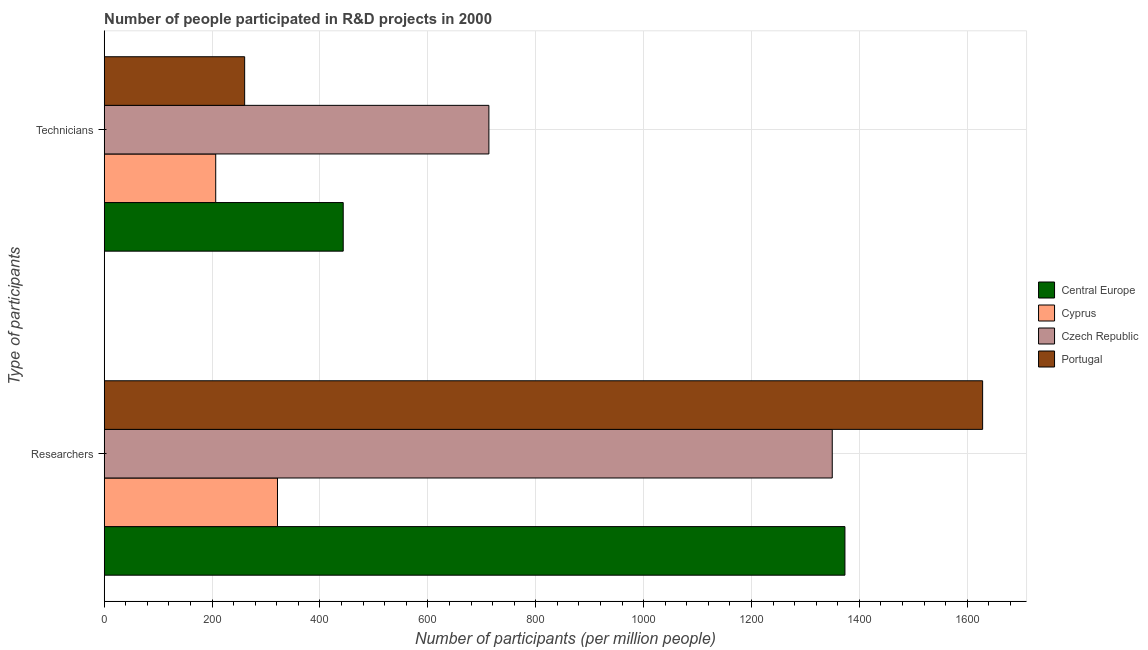How many groups of bars are there?
Provide a short and direct response. 2. Are the number of bars on each tick of the Y-axis equal?
Offer a terse response. Yes. What is the label of the 2nd group of bars from the top?
Make the answer very short. Researchers. What is the number of technicians in Czech Republic?
Provide a short and direct response. 713.14. Across all countries, what is the maximum number of technicians?
Offer a terse response. 713.14. Across all countries, what is the minimum number of researchers?
Ensure brevity in your answer.  321.22. In which country was the number of researchers maximum?
Make the answer very short. Portugal. In which country was the number of technicians minimum?
Ensure brevity in your answer.  Cyprus. What is the total number of technicians in the graph?
Your response must be concise. 1623.32. What is the difference between the number of researchers in Central Europe and that in Czech Republic?
Provide a short and direct response. 23.52. What is the difference between the number of researchers in Central Europe and the number of technicians in Portugal?
Offer a terse response. 1112.86. What is the average number of researchers per country?
Make the answer very short. 1168.15. What is the difference between the number of technicians and number of researchers in Central Europe?
Provide a succinct answer. -930.13. In how many countries, is the number of technicians greater than 640 ?
Offer a terse response. 1. What is the ratio of the number of technicians in Central Europe to that in Czech Republic?
Make the answer very short. 0.62. Is the number of technicians in Portugal less than that in Cyprus?
Offer a terse response. No. What does the 1st bar from the bottom in Technicians represents?
Keep it short and to the point. Central Europe. How many countries are there in the graph?
Keep it short and to the point. 4. Does the graph contain grids?
Provide a succinct answer. Yes. How are the legend labels stacked?
Your answer should be very brief. Vertical. What is the title of the graph?
Give a very brief answer. Number of people participated in R&D projects in 2000. What is the label or title of the X-axis?
Your answer should be very brief. Number of participants (per million people). What is the label or title of the Y-axis?
Give a very brief answer. Type of participants. What is the Number of participants (per million people) in Central Europe in Researchers?
Your answer should be very brief. 1373.22. What is the Number of participants (per million people) of Cyprus in Researchers?
Make the answer very short. 321.22. What is the Number of participants (per million people) of Czech Republic in Researchers?
Give a very brief answer. 1349.7. What is the Number of participants (per million people) in Portugal in Researchers?
Keep it short and to the point. 1628.47. What is the Number of participants (per million people) of Central Europe in Technicians?
Keep it short and to the point. 443.09. What is the Number of participants (per million people) of Cyprus in Technicians?
Keep it short and to the point. 206.72. What is the Number of participants (per million people) in Czech Republic in Technicians?
Make the answer very short. 713.14. What is the Number of participants (per million people) in Portugal in Technicians?
Your answer should be very brief. 260.36. Across all Type of participants, what is the maximum Number of participants (per million people) of Central Europe?
Make the answer very short. 1373.22. Across all Type of participants, what is the maximum Number of participants (per million people) in Cyprus?
Provide a short and direct response. 321.22. Across all Type of participants, what is the maximum Number of participants (per million people) in Czech Republic?
Give a very brief answer. 1349.7. Across all Type of participants, what is the maximum Number of participants (per million people) in Portugal?
Your answer should be compact. 1628.47. Across all Type of participants, what is the minimum Number of participants (per million people) of Central Europe?
Your answer should be very brief. 443.09. Across all Type of participants, what is the minimum Number of participants (per million people) in Cyprus?
Your answer should be compact. 206.72. Across all Type of participants, what is the minimum Number of participants (per million people) in Czech Republic?
Offer a terse response. 713.14. Across all Type of participants, what is the minimum Number of participants (per million people) of Portugal?
Your answer should be very brief. 260.36. What is the total Number of participants (per million people) of Central Europe in the graph?
Your answer should be very brief. 1816.32. What is the total Number of participants (per million people) in Cyprus in the graph?
Make the answer very short. 527.94. What is the total Number of participants (per million people) of Czech Republic in the graph?
Offer a very short reply. 2062.85. What is the total Number of participants (per million people) in Portugal in the graph?
Give a very brief answer. 1888.83. What is the difference between the Number of participants (per million people) of Central Europe in Researchers and that in Technicians?
Your answer should be compact. 930.13. What is the difference between the Number of participants (per million people) of Cyprus in Researchers and that in Technicians?
Your answer should be compact. 114.49. What is the difference between the Number of participants (per million people) in Czech Republic in Researchers and that in Technicians?
Provide a succinct answer. 636.56. What is the difference between the Number of participants (per million people) in Portugal in Researchers and that in Technicians?
Keep it short and to the point. 1368.11. What is the difference between the Number of participants (per million people) of Central Europe in Researchers and the Number of participants (per million people) of Cyprus in Technicians?
Your answer should be compact. 1166.5. What is the difference between the Number of participants (per million people) in Central Europe in Researchers and the Number of participants (per million people) in Czech Republic in Technicians?
Provide a succinct answer. 660.08. What is the difference between the Number of participants (per million people) in Central Europe in Researchers and the Number of participants (per million people) in Portugal in Technicians?
Ensure brevity in your answer.  1112.86. What is the difference between the Number of participants (per million people) of Cyprus in Researchers and the Number of participants (per million people) of Czech Republic in Technicians?
Your answer should be compact. -391.93. What is the difference between the Number of participants (per million people) in Cyprus in Researchers and the Number of participants (per million people) in Portugal in Technicians?
Provide a succinct answer. 60.86. What is the difference between the Number of participants (per million people) in Czech Republic in Researchers and the Number of participants (per million people) in Portugal in Technicians?
Offer a very short reply. 1089.34. What is the average Number of participants (per million people) in Central Europe per Type of participants?
Give a very brief answer. 908.16. What is the average Number of participants (per million people) in Cyprus per Type of participants?
Make the answer very short. 263.97. What is the average Number of participants (per million people) of Czech Republic per Type of participants?
Your response must be concise. 1031.42. What is the average Number of participants (per million people) in Portugal per Type of participants?
Provide a succinct answer. 944.41. What is the difference between the Number of participants (per million people) of Central Europe and Number of participants (per million people) of Cyprus in Researchers?
Your answer should be very brief. 1052.01. What is the difference between the Number of participants (per million people) of Central Europe and Number of participants (per million people) of Czech Republic in Researchers?
Provide a succinct answer. 23.52. What is the difference between the Number of participants (per million people) in Central Europe and Number of participants (per million people) in Portugal in Researchers?
Your answer should be compact. -255.25. What is the difference between the Number of participants (per million people) in Cyprus and Number of participants (per million people) in Czech Republic in Researchers?
Ensure brevity in your answer.  -1028.48. What is the difference between the Number of participants (per million people) of Cyprus and Number of participants (per million people) of Portugal in Researchers?
Give a very brief answer. -1307.25. What is the difference between the Number of participants (per million people) in Czech Republic and Number of participants (per million people) in Portugal in Researchers?
Offer a very short reply. -278.77. What is the difference between the Number of participants (per million people) in Central Europe and Number of participants (per million people) in Cyprus in Technicians?
Your answer should be compact. 236.37. What is the difference between the Number of participants (per million people) in Central Europe and Number of participants (per million people) in Czech Republic in Technicians?
Make the answer very short. -270.05. What is the difference between the Number of participants (per million people) of Central Europe and Number of participants (per million people) of Portugal in Technicians?
Provide a succinct answer. 182.73. What is the difference between the Number of participants (per million people) in Cyprus and Number of participants (per million people) in Czech Republic in Technicians?
Your answer should be compact. -506.42. What is the difference between the Number of participants (per million people) in Cyprus and Number of participants (per million people) in Portugal in Technicians?
Ensure brevity in your answer.  -53.63. What is the difference between the Number of participants (per million people) in Czech Republic and Number of participants (per million people) in Portugal in Technicians?
Give a very brief answer. 452.79. What is the ratio of the Number of participants (per million people) of Central Europe in Researchers to that in Technicians?
Your answer should be very brief. 3.1. What is the ratio of the Number of participants (per million people) in Cyprus in Researchers to that in Technicians?
Offer a very short reply. 1.55. What is the ratio of the Number of participants (per million people) in Czech Republic in Researchers to that in Technicians?
Make the answer very short. 1.89. What is the ratio of the Number of participants (per million people) in Portugal in Researchers to that in Technicians?
Offer a terse response. 6.25. What is the difference between the highest and the second highest Number of participants (per million people) of Central Europe?
Ensure brevity in your answer.  930.13. What is the difference between the highest and the second highest Number of participants (per million people) of Cyprus?
Offer a terse response. 114.49. What is the difference between the highest and the second highest Number of participants (per million people) in Czech Republic?
Offer a terse response. 636.56. What is the difference between the highest and the second highest Number of participants (per million people) of Portugal?
Your answer should be very brief. 1368.11. What is the difference between the highest and the lowest Number of participants (per million people) in Central Europe?
Offer a very short reply. 930.13. What is the difference between the highest and the lowest Number of participants (per million people) in Cyprus?
Make the answer very short. 114.49. What is the difference between the highest and the lowest Number of participants (per million people) of Czech Republic?
Your response must be concise. 636.56. What is the difference between the highest and the lowest Number of participants (per million people) of Portugal?
Keep it short and to the point. 1368.11. 